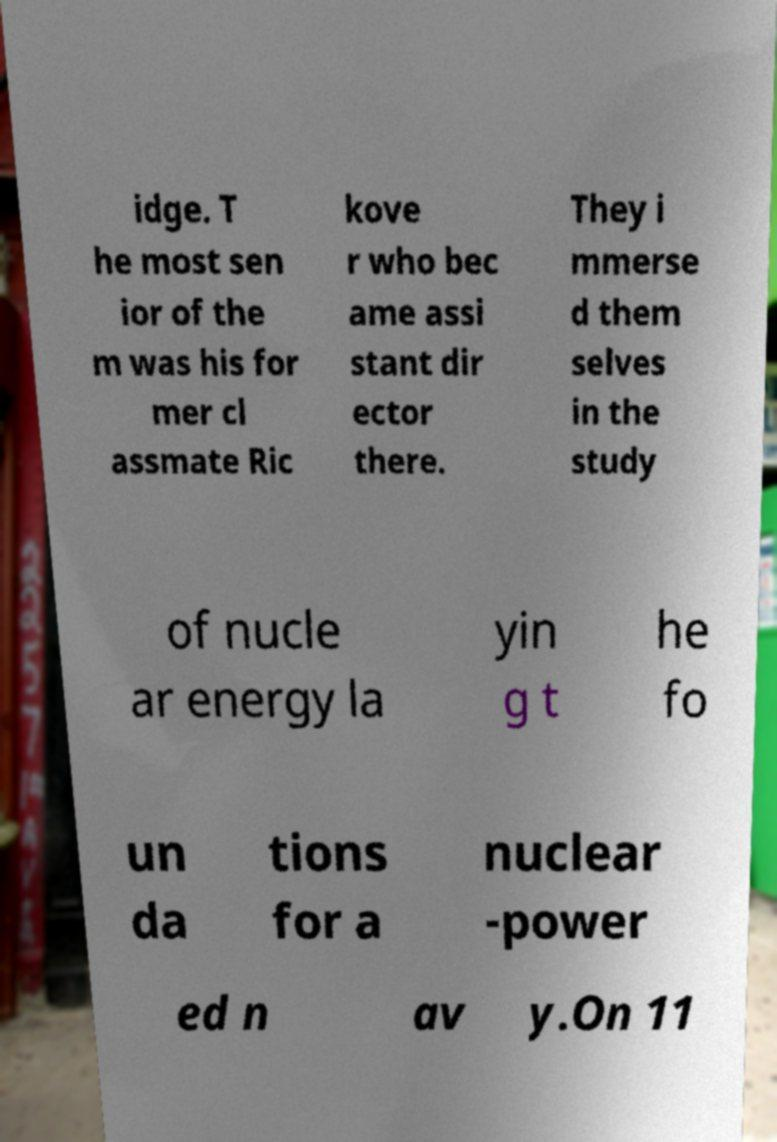Please identify and transcribe the text found in this image. idge. T he most sen ior of the m was his for mer cl assmate Ric kove r who bec ame assi stant dir ector there. They i mmerse d them selves in the study of nucle ar energy la yin g t he fo un da tions for a nuclear -power ed n av y.On 11 